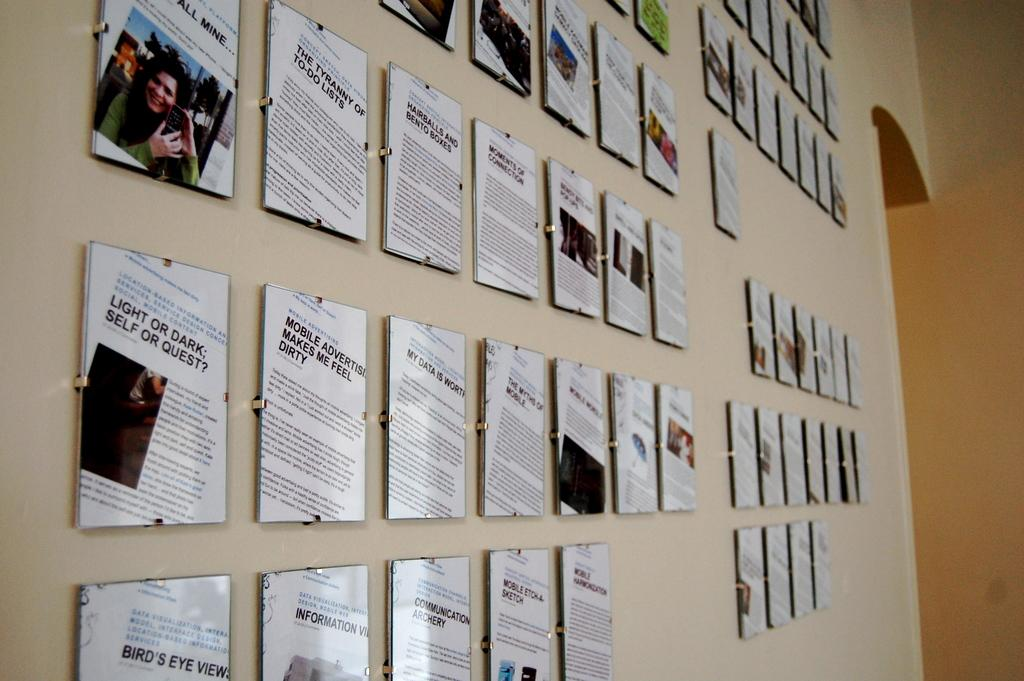Provide a one-sentence caption for the provided image. The wall is full of prints of articles like "Mobile Etch-A-Sketch" and Light or Dark; Self or Quest?". 